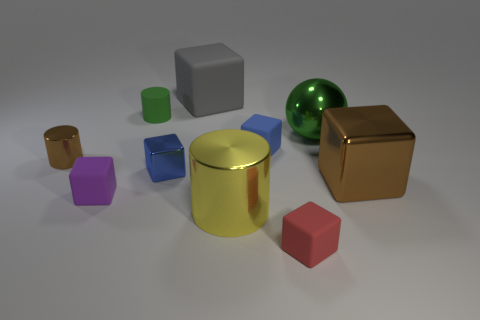Subtract all brown blocks. How many blocks are left? 5 Subtract all big cubes. How many cubes are left? 4 Subtract all cyan balls. Subtract all green cylinders. How many balls are left? 1 Subtract all spheres. How many objects are left? 9 Add 2 small blue matte objects. How many small blue matte objects exist? 3 Subtract 1 gray cubes. How many objects are left? 9 Subtract all green cylinders. Subtract all big yellow shiny objects. How many objects are left? 8 Add 6 large metal blocks. How many large metal blocks are left? 7 